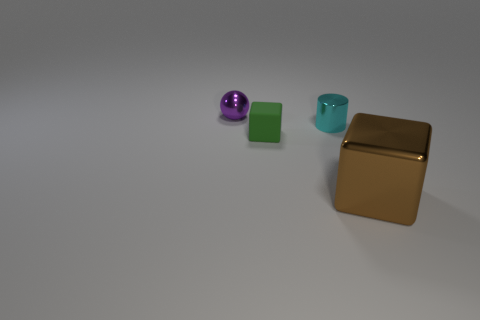Add 1 big cubes. How many objects exist? 5 Subtract all spheres. How many objects are left? 3 Subtract all tiny shiny things. Subtract all tiny red metallic cylinders. How many objects are left? 2 Add 3 tiny green cubes. How many tiny green cubes are left? 4 Add 2 small green things. How many small green things exist? 3 Subtract 0 gray balls. How many objects are left? 4 